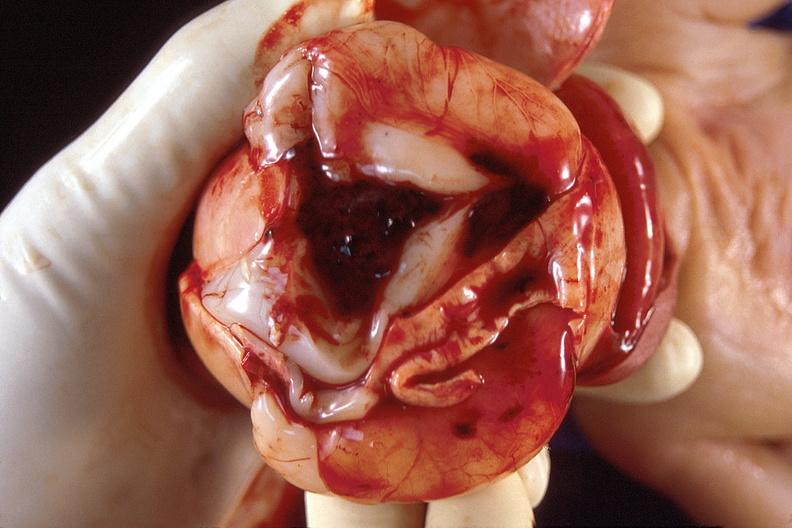what does this image show?
Answer the question using a single word or phrase. Brain 